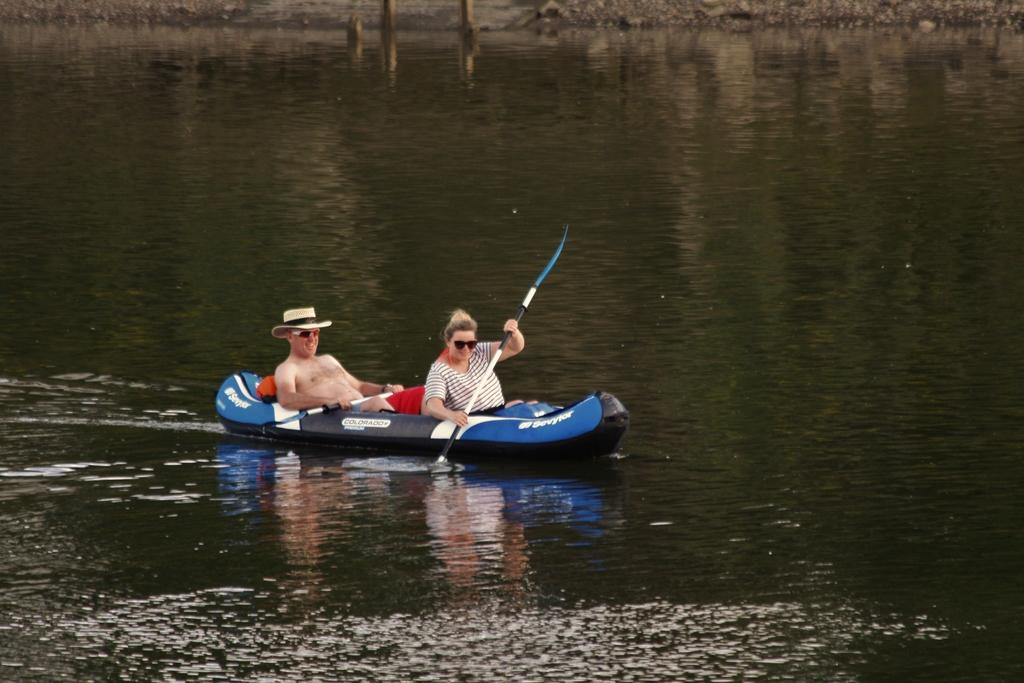How many people are in the image? There are two persons in the image. What are the persons doing in the image? The two persons are sitting in a boat. What are the persons holding in the image? They are holding paddles. Can you describe the attire of one of the persons? One of the men is wearing a hat. What can be seen in the background of the image? There is water visible in the background of the image. What type of letters can be seen on the wheel of the van in the image? There is no van or wheel present in the image; it features two persons sitting in a boat. 